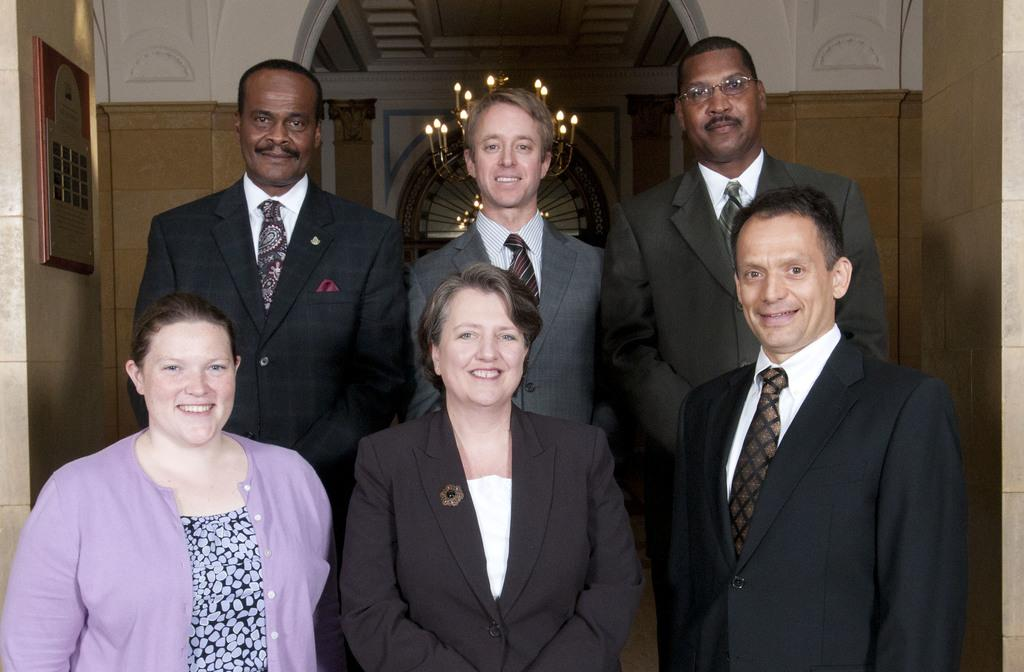What can be seen in the front of the image? There are persons standing in the front of the image. What is the facial expression of the persons? The persons are smiling. What is located on the left side of the wall in the image? There is a frame on the left side of the wall in the image. What can be seen in the background of the image? In the background, there are candles on a stand. What type of wire is being used to organize the candles on the stand? There is no wire visible in the image, and the candles are not being organized in any specific way. 